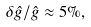Convert formula to latex. <formula><loc_0><loc_0><loc_500><loc_500>\delta \hat { g } / \hat { g } \approx 5 \% ,</formula> 